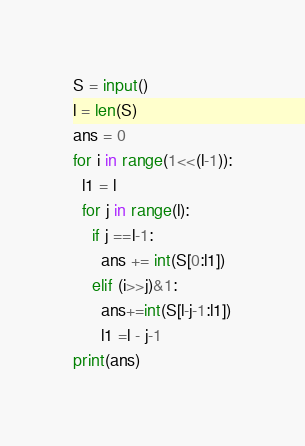<code> <loc_0><loc_0><loc_500><loc_500><_Python_>S = input()
l = len(S)
ans = 0
for i in range(1<<(l-1)):
  l1 = l
  for j in range(l):
    if j ==l-1:
      ans += int(S[0:l1])
    elif (i>>j)&1:
      ans+=int(S[l-j-1:l1])
      l1 =l - j-1
print(ans)</code> 